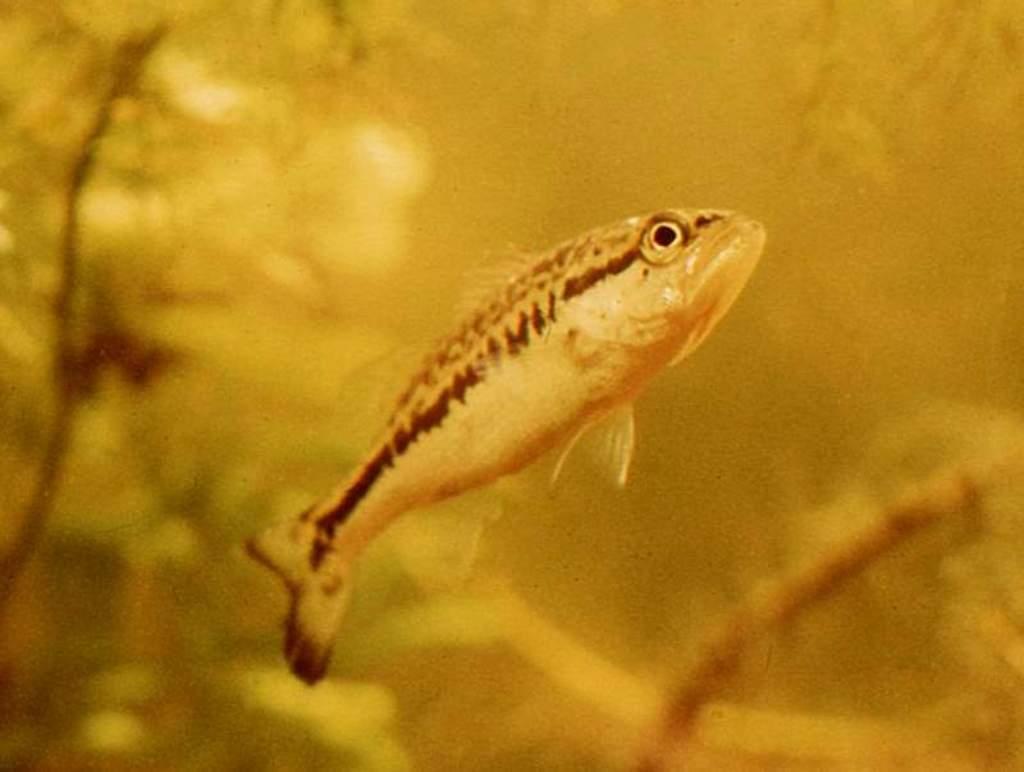In one or two sentences, can you explain what this image depicts? In this image, we can see the background as yellow color and there is also a fish which is present at the center. 